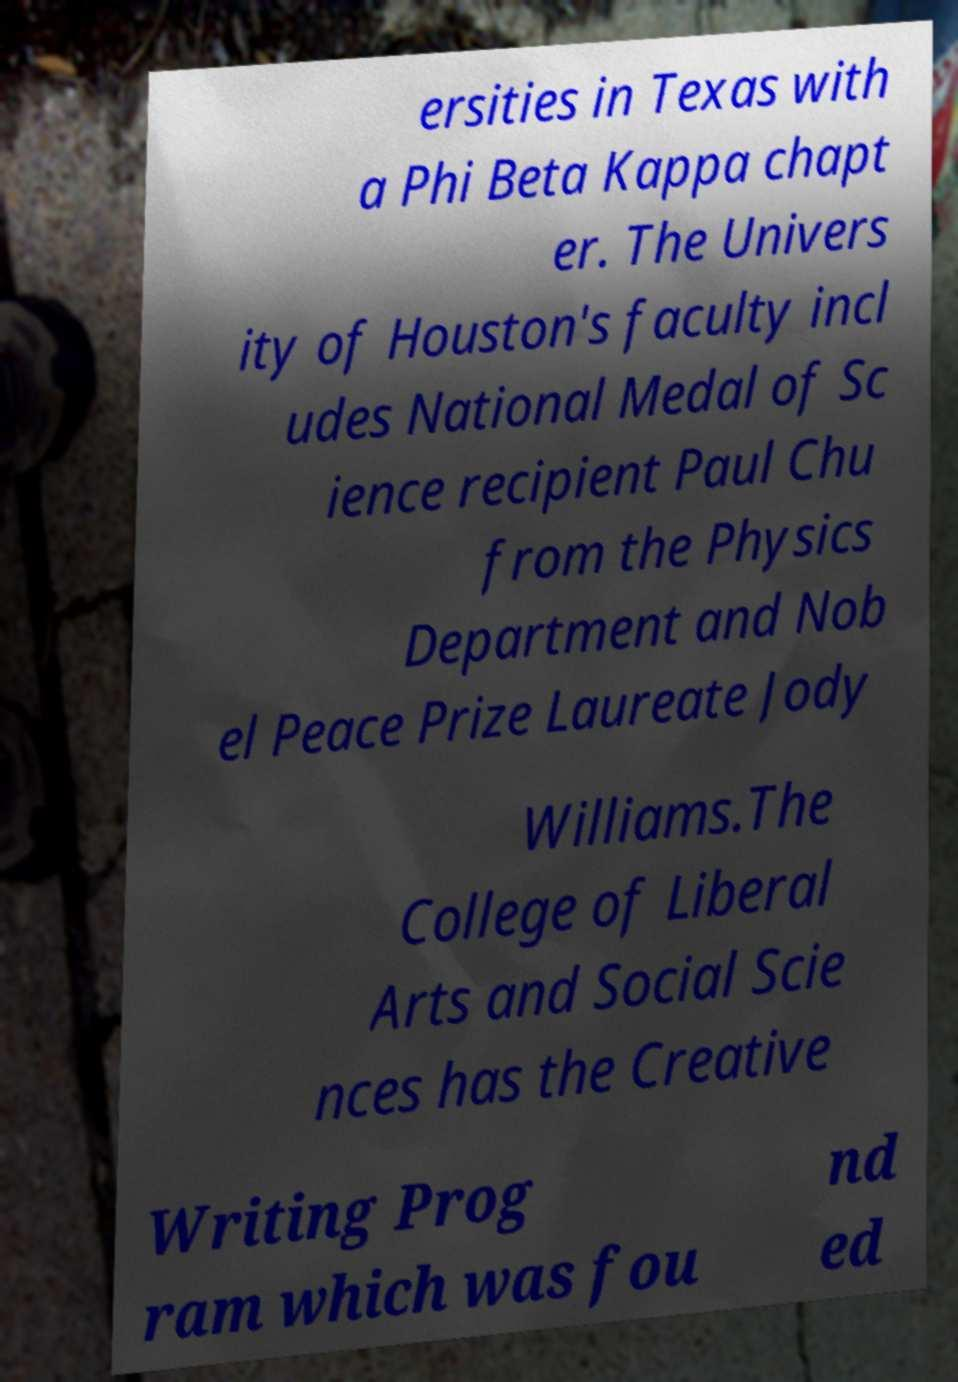Can you accurately transcribe the text from the provided image for me? ersities in Texas with a Phi Beta Kappa chapt er. The Univers ity of Houston's faculty incl udes National Medal of Sc ience recipient Paul Chu from the Physics Department and Nob el Peace Prize Laureate Jody Williams.The College of Liberal Arts and Social Scie nces has the Creative Writing Prog ram which was fou nd ed 